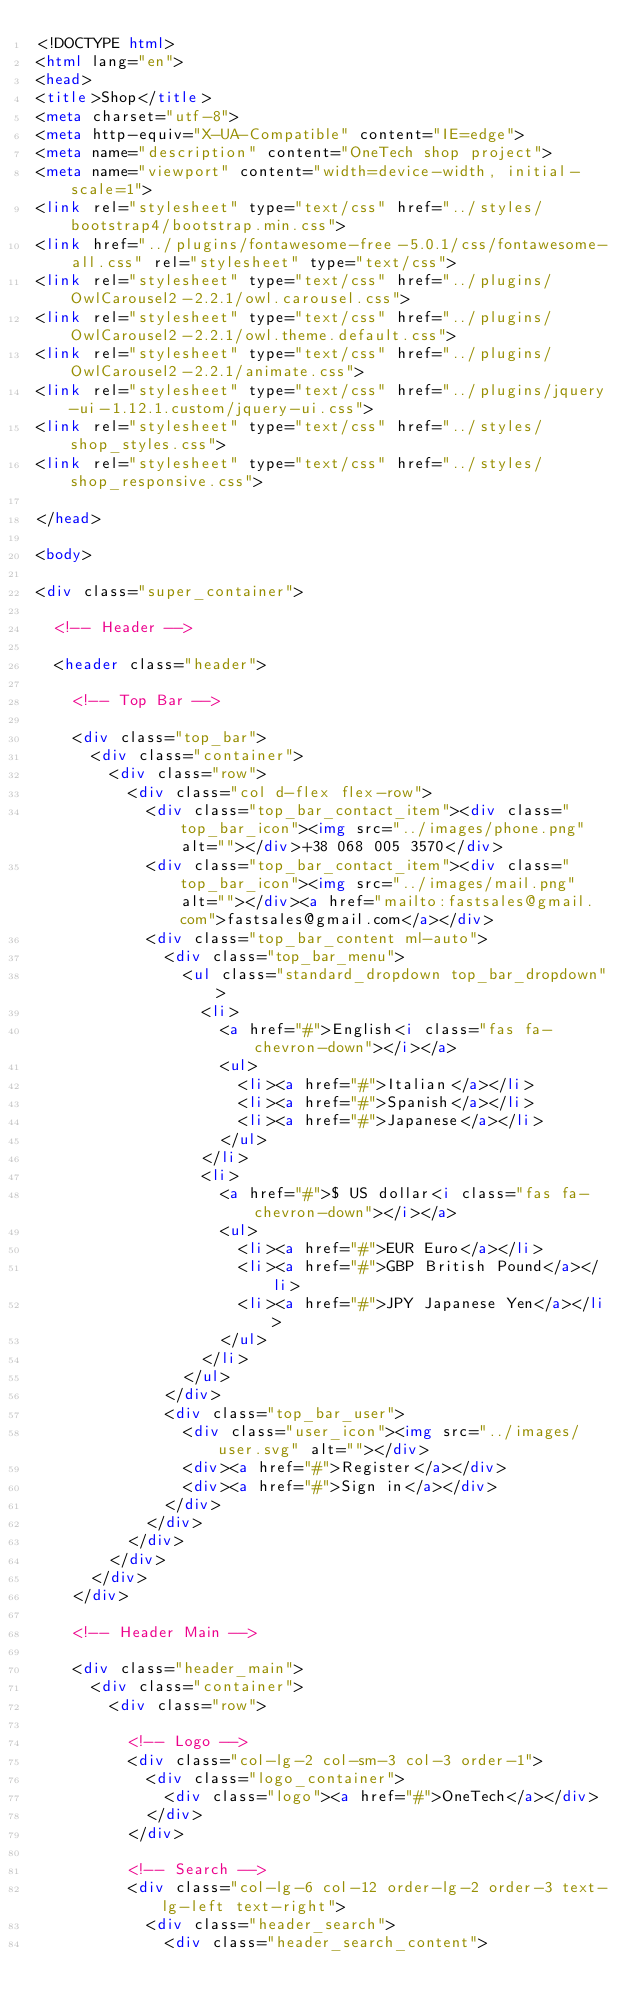<code> <loc_0><loc_0><loc_500><loc_500><_HTML_><!DOCTYPE html>
<html lang="en">
<head>
<title>Shop</title>
<meta charset="utf-8">
<meta http-equiv="X-UA-Compatible" content="IE=edge">
<meta name="description" content="OneTech shop project">
<meta name="viewport" content="width=device-width, initial-scale=1">
<link rel="stylesheet" type="text/css" href="../styles/bootstrap4/bootstrap.min.css">
<link href="../plugins/fontawesome-free-5.0.1/css/fontawesome-all.css" rel="stylesheet" type="text/css">
<link rel="stylesheet" type="text/css" href="../plugins/OwlCarousel2-2.2.1/owl.carousel.css">
<link rel="stylesheet" type="text/css" href="../plugins/OwlCarousel2-2.2.1/owl.theme.default.css">
<link rel="stylesheet" type="text/css" href="../plugins/OwlCarousel2-2.2.1/animate.css">
<link rel="stylesheet" type="text/css" href="../plugins/jquery-ui-1.12.1.custom/jquery-ui.css">
<link rel="stylesheet" type="text/css" href="../styles/shop_styles.css">
<link rel="stylesheet" type="text/css" href="../styles/shop_responsive.css">

</head>

<body>

<div class="super_container">

	<!-- Header -->

	<header class="header">

		<!-- Top Bar -->

		<div class="top_bar">
			<div class="container">
				<div class="row">
					<div class="col d-flex flex-row">
						<div class="top_bar_contact_item"><div class="top_bar_icon"><img src="../images/phone.png" alt=""></div>+38 068 005 3570</div>
						<div class="top_bar_contact_item"><div class="top_bar_icon"><img src="../images/mail.png" alt=""></div><a href="mailto:fastsales@gmail.com">fastsales@gmail.com</a></div>
						<div class="top_bar_content ml-auto">
							<div class="top_bar_menu">
								<ul class="standard_dropdown top_bar_dropdown">
									<li>
										<a href="#">English<i class="fas fa-chevron-down"></i></a>
										<ul>
											<li><a href="#">Italian</a></li>
											<li><a href="#">Spanish</a></li>
											<li><a href="#">Japanese</a></li>
										</ul>
									</li>
									<li>
										<a href="#">$ US dollar<i class="fas fa-chevron-down"></i></a>
										<ul>
											<li><a href="#">EUR Euro</a></li>
											<li><a href="#">GBP British Pound</a></li>
											<li><a href="#">JPY Japanese Yen</a></li>
										</ul>
									</li>
								</ul>
							</div>
							<div class="top_bar_user">
								<div class="user_icon"><img src="../images/user.svg" alt=""></div>
								<div><a href="#">Register</a></div>
								<div><a href="#">Sign in</a></div>
							</div>
						</div>
					</div>
				</div>
			</div>
		</div>

		<!-- Header Main -->

		<div class="header_main">
			<div class="container">
				<div class="row">

					<!-- Logo -->
					<div class="col-lg-2 col-sm-3 col-3 order-1">
						<div class="logo_container">
							<div class="logo"><a href="#">OneTech</a></div>
						</div>
					</div>

					<!-- Search -->
					<div class="col-lg-6 col-12 order-lg-2 order-3 text-lg-left text-right">
						<div class="header_search">
							<div class="header_search_content"></code> 